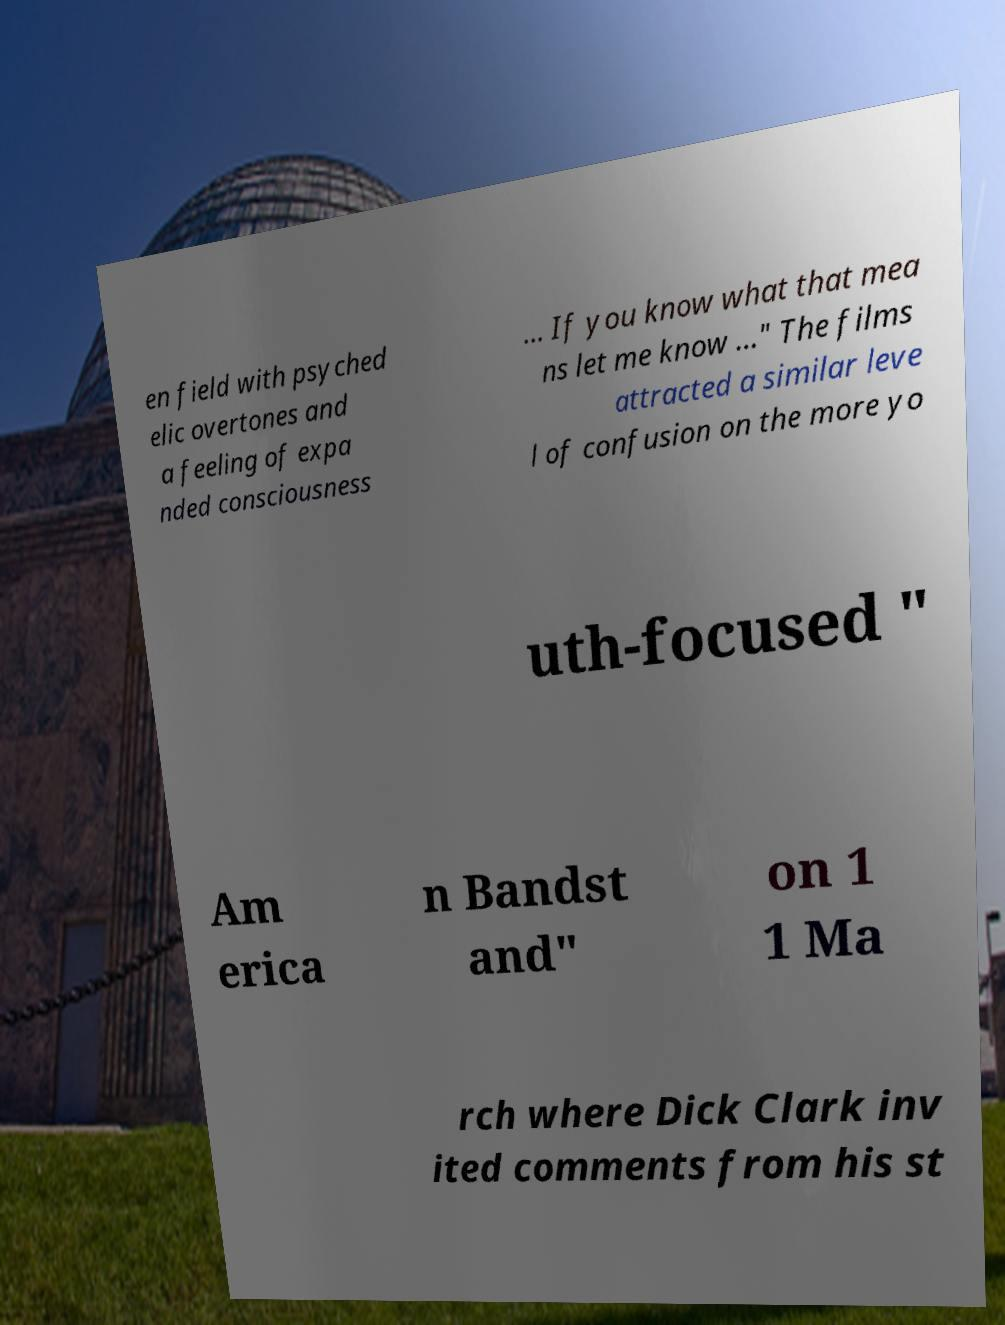Can you accurately transcribe the text from the provided image for me? en field with psyched elic overtones and a feeling of expa nded consciousness … If you know what that mea ns let me know …" The films attracted a similar leve l of confusion on the more yo uth-focused " Am erica n Bandst and" on 1 1 Ma rch where Dick Clark inv ited comments from his st 